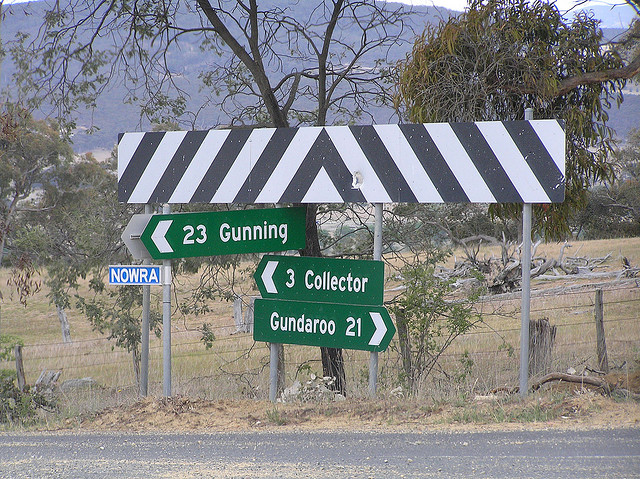<image>How far is Bennett? It is unknown how far Bennett is as it's not specified. How far is Bennett? I don't know how far Bennett is. It is not mentioned in the sign. 